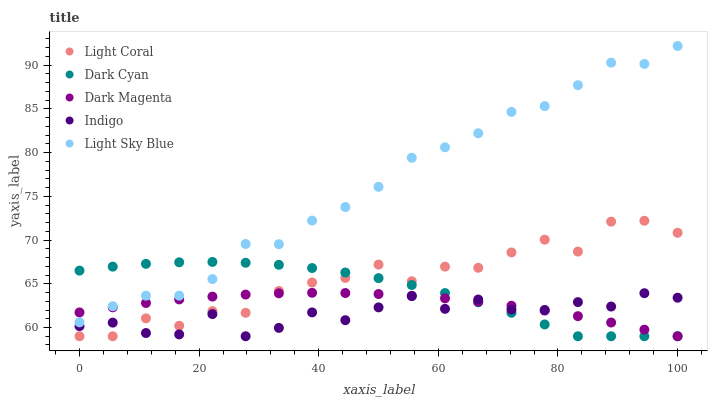Does Indigo have the minimum area under the curve?
Answer yes or no. Yes. Does Light Sky Blue have the maximum area under the curve?
Answer yes or no. Yes. Does Dark Cyan have the minimum area under the curve?
Answer yes or no. No. Does Dark Cyan have the maximum area under the curve?
Answer yes or no. No. Is Dark Magenta the smoothest?
Answer yes or no. Yes. Is Light Coral the roughest?
Answer yes or no. Yes. Is Dark Cyan the smoothest?
Answer yes or no. No. Is Dark Cyan the roughest?
Answer yes or no. No. Does Light Coral have the lowest value?
Answer yes or no. Yes. Does Light Sky Blue have the lowest value?
Answer yes or no. No. Does Light Sky Blue have the highest value?
Answer yes or no. Yes. Does Dark Cyan have the highest value?
Answer yes or no. No. Is Light Coral less than Light Sky Blue?
Answer yes or no. Yes. Is Light Sky Blue greater than Indigo?
Answer yes or no. Yes. Does Dark Magenta intersect Dark Cyan?
Answer yes or no. Yes. Is Dark Magenta less than Dark Cyan?
Answer yes or no. No. Is Dark Magenta greater than Dark Cyan?
Answer yes or no. No. Does Light Coral intersect Light Sky Blue?
Answer yes or no. No. 